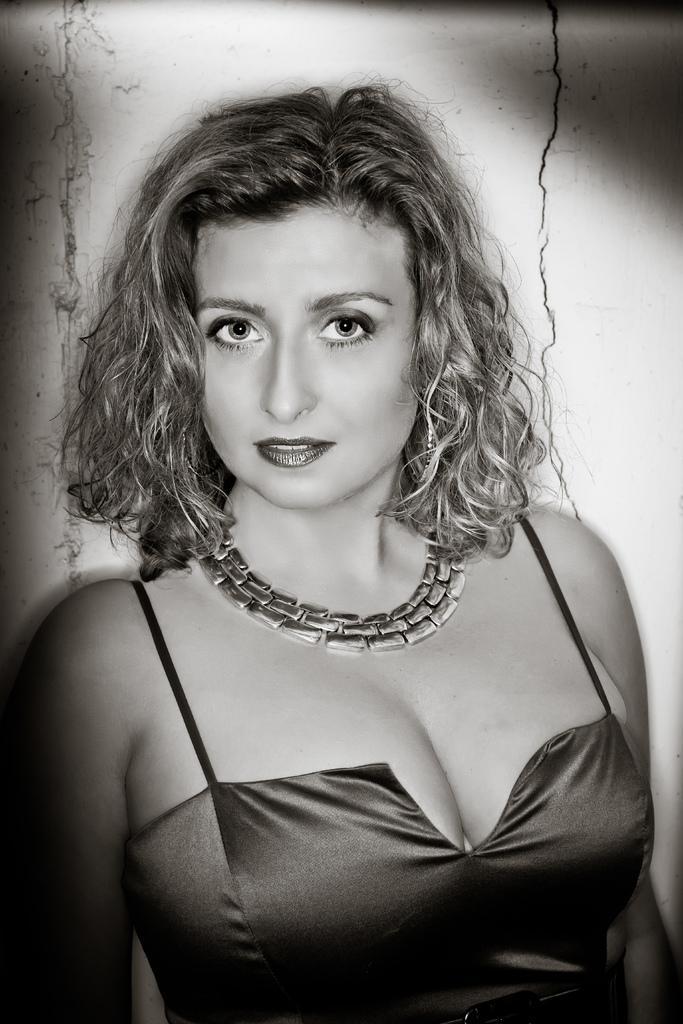In one or two sentences, can you explain what this image depicts? In this image we can see a lady. There are a few cracks in the wall behind a lady. 